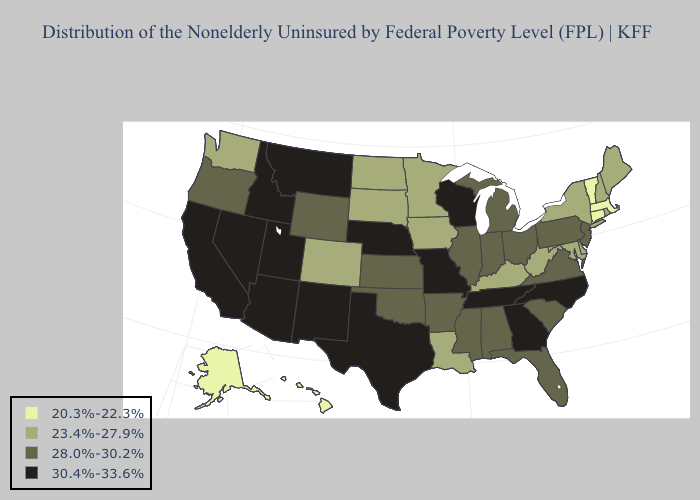What is the lowest value in states that border Indiana?
Give a very brief answer. 23.4%-27.9%. Name the states that have a value in the range 28.0%-30.2%?
Quick response, please. Alabama, Arkansas, Florida, Illinois, Indiana, Kansas, Michigan, Mississippi, New Jersey, Ohio, Oklahoma, Oregon, Pennsylvania, South Carolina, Virginia, Wyoming. Does North Carolina have the lowest value in the South?
Be succinct. No. Name the states that have a value in the range 28.0%-30.2%?
Concise answer only. Alabama, Arkansas, Florida, Illinois, Indiana, Kansas, Michigan, Mississippi, New Jersey, Ohio, Oklahoma, Oregon, Pennsylvania, South Carolina, Virginia, Wyoming. Among the states that border North Dakota , does Minnesota have the highest value?
Quick response, please. No. What is the lowest value in the USA?
Keep it brief. 20.3%-22.3%. What is the value of New Jersey?
Answer briefly. 28.0%-30.2%. Name the states that have a value in the range 30.4%-33.6%?
Write a very short answer. Arizona, California, Georgia, Idaho, Missouri, Montana, Nebraska, Nevada, New Mexico, North Carolina, Tennessee, Texas, Utah, Wisconsin. Which states hav the highest value in the MidWest?
Concise answer only. Missouri, Nebraska, Wisconsin. What is the value of Tennessee?
Quick response, please. 30.4%-33.6%. What is the highest value in the USA?
Be succinct. 30.4%-33.6%. What is the value of Iowa?
Short answer required. 23.4%-27.9%. Does Arkansas have the lowest value in the USA?
Be succinct. No. What is the lowest value in the MidWest?
Concise answer only. 23.4%-27.9%. What is the value of Nevada?
Quick response, please. 30.4%-33.6%. 